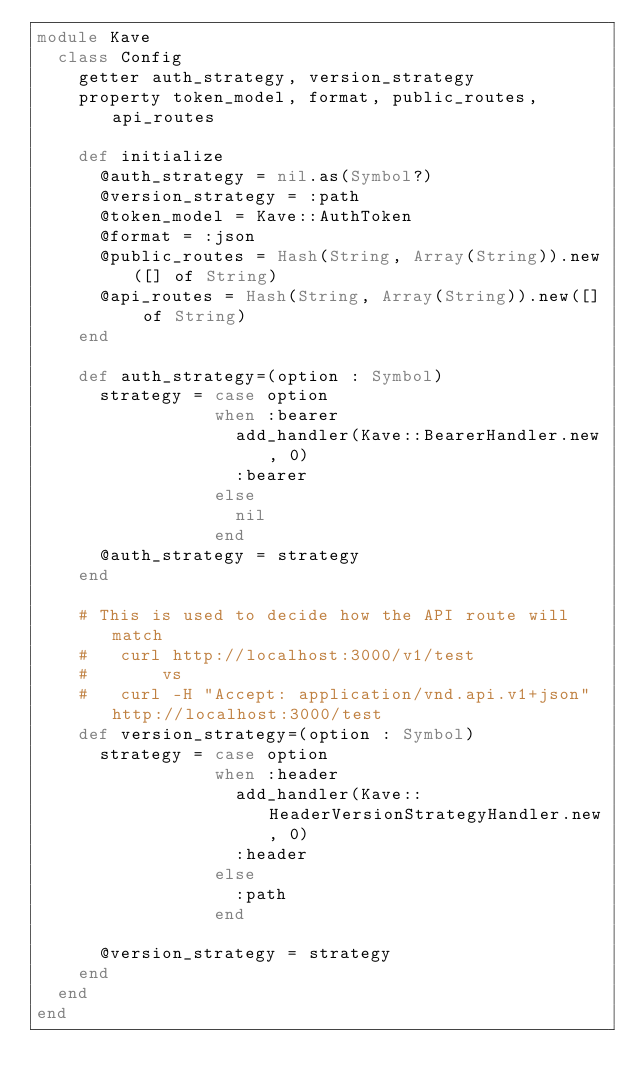<code> <loc_0><loc_0><loc_500><loc_500><_Crystal_>module Kave
  class Config
    getter auth_strategy, version_strategy
    property token_model, format, public_routes, api_routes

    def initialize
      @auth_strategy = nil.as(Symbol?)
      @version_strategy = :path
      @token_model = Kave::AuthToken
      @format = :json
      @public_routes = Hash(String, Array(String)).new([] of String)
      @api_routes = Hash(String, Array(String)).new([] of String)
    end

    def auth_strategy=(option : Symbol)
      strategy = case option
                 when :bearer
                   add_handler(Kave::BearerHandler.new, 0)
                   :bearer
                 else
                   nil
                 end
      @auth_strategy = strategy
    end

    # This is used to decide how the API route will match
    #   curl http://localhost:3000/v1/test
    #       vs
    #   curl -H "Accept: application/vnd.api.v1+json" http://localhost:3000/test
    def version_strategy=(option : Symbol)
      strategy = case option
                 when :header
                   add_handler(Kave::HeaderVersionStrategyHandler.new, 0)
                   :header
                 else
                   :path
                 end

      @version_strategy = strategy
    end
  end
end
</code> 